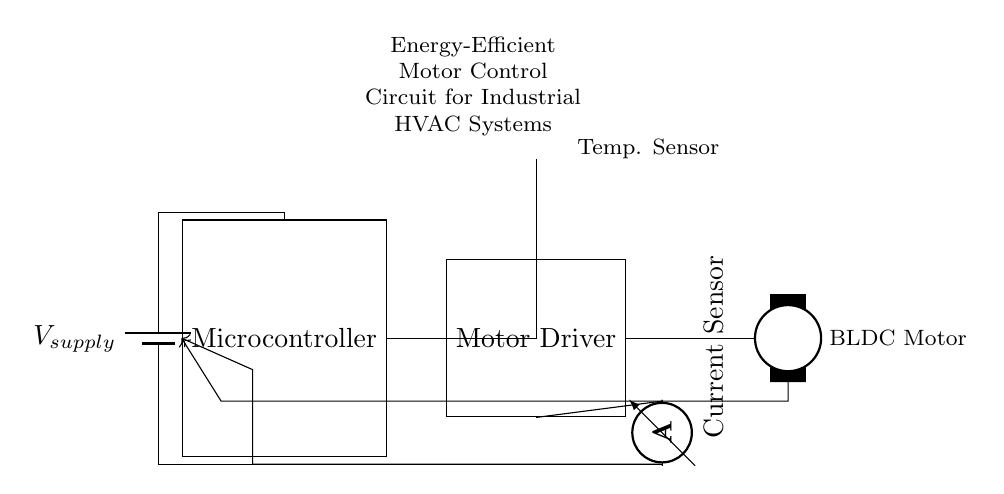What is the power supply represented in the circuit? The power supply is denoted as a battery symbol, indicating it provides the necessary voltage to the circuit components.
Answer: Battery What type of motor is used in this circuit? The circuit shows a Brushless DC motor (BLDC Motor), which is indicated by the specific symbol for this type of motor in the diagram.
Answer: BLDC Motor How many sensors are present in the circuit? There are two sensors in the circuit: a temperature sensor and a current sensor, each represented by their respective symbols.
Answer: Two What is the role of the microcontroller in this circuit? The microcontroller processes inputs from the temperature sensor and current sensor, then controls the motor driver based on this data, facilitating efficient motor control.
Answer: Control Explain the feedback mechanism in the circuit. The feedback mechanism consists of two paths: one from the current sensor to the microcontroller and another from the motor to the microcontroller. This enables the microcontroller to adjust the motor's operation based on real-time data from both sensors, ensuring optimal performance and efficiency.
Answer: Feedback loop What is the connection between the microcontroller and the motor driver? The microcontroller is directly connected to the motor driver, allowing it to send control signals to the driver that regulates the operation of the motor.
Answer: Direct connection Which component measures current in this circuit? The current sensor is represented by an ammeter symbol and is specifically included to monitor the current flowing to the motor for feedback to the microcontroller.
Answer: Current Sensor 